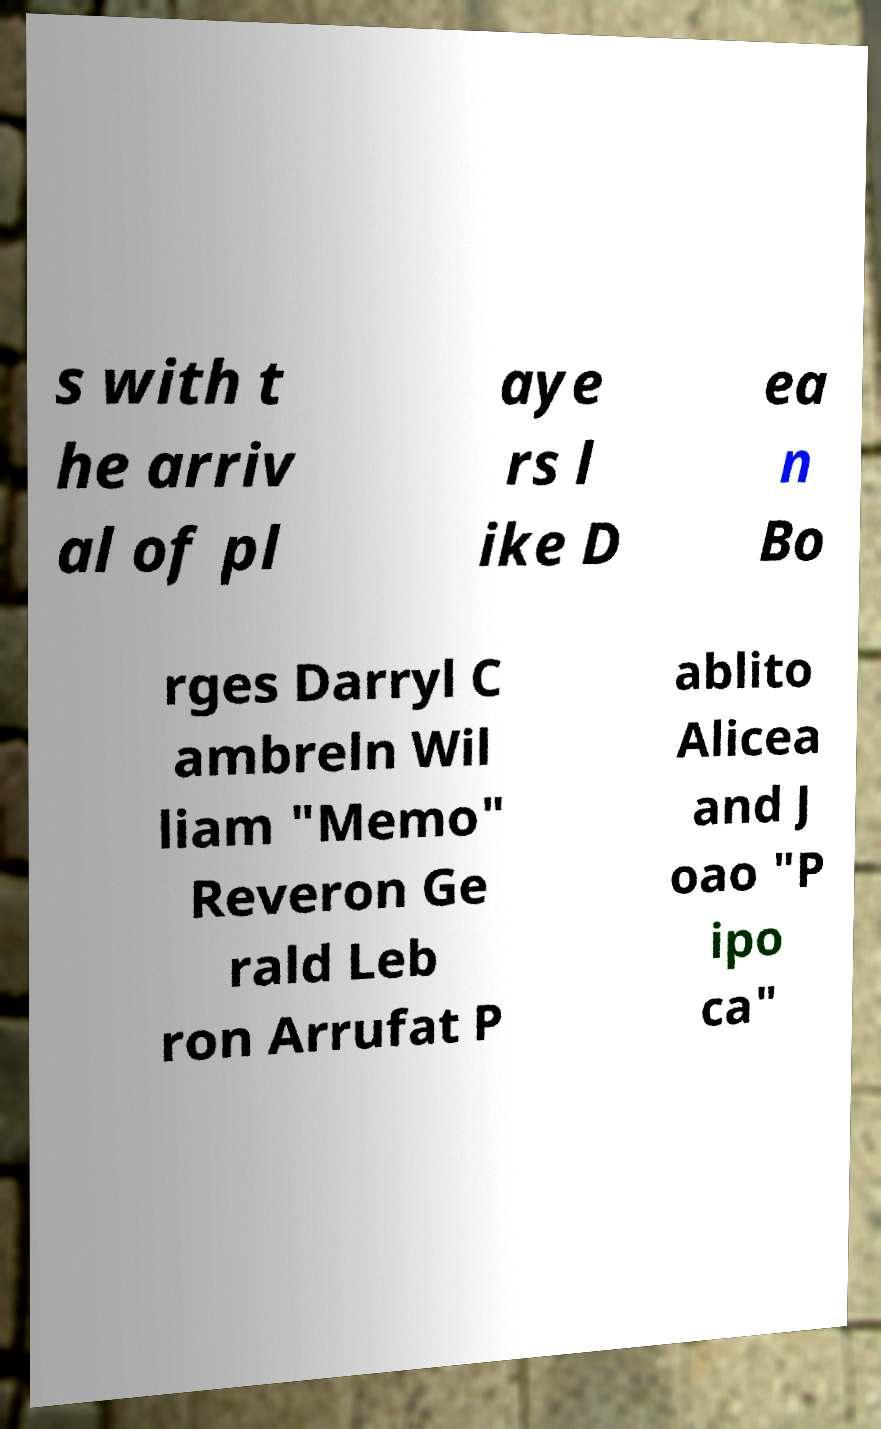There's text embedded in this image that I need extracted. Can you transcribe it verbatim? s with t he arriv al of pl aye rs l ike D ea n Bo rges Darryl C ambreln Wil liam "Memo" Reveron Ge rald Leb ron Arrufat P ablito Alicea and J oao "P ipo ca" 